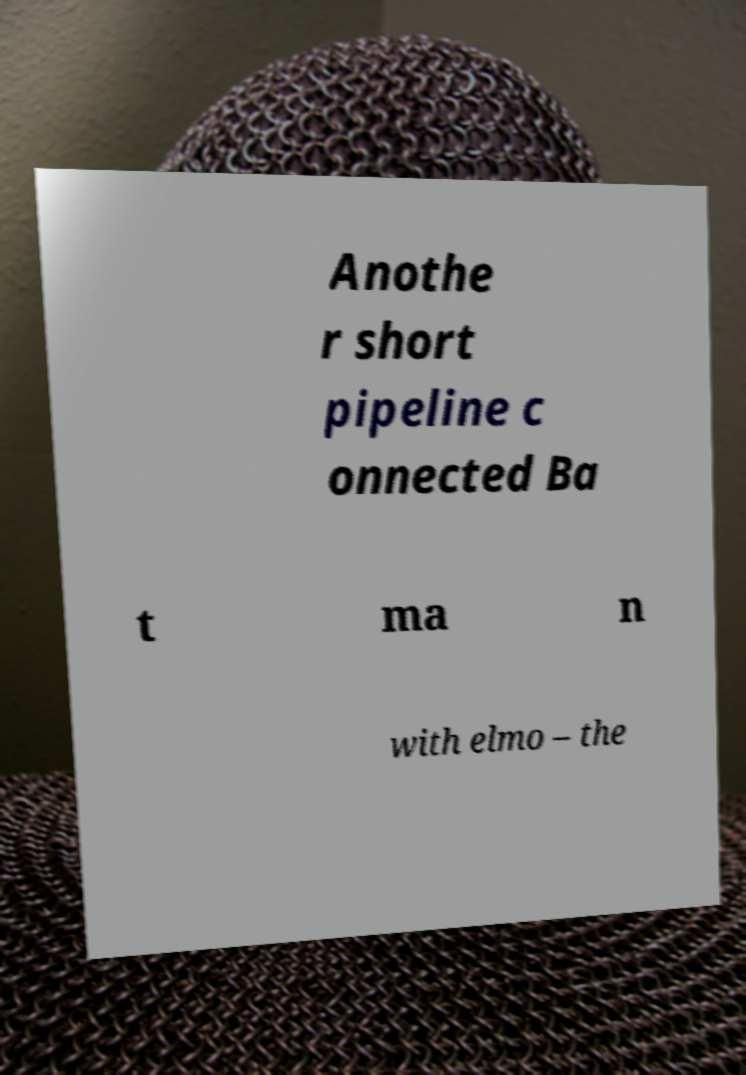Please identify and transcribe the text found in this image. Anothe r short pipeline c onnected Ba t ma n with elmo – the 